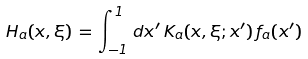Convert formula to latex. <formula><loc_0><loc_0><loc_500><loc_500>H _ { a } ( x , \xi ) \, = \, \int _ { - 1 } ^ { 1 } \, d x ^ { \prime } \, K _ { a } ( x , \xi ; x ^ { \prime } ) \, f _ { a } ( x ^ { \prime } )</formula> 